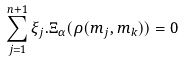Convert formula to latex. <formula><loc_0><loc_0><loc_500><loc_500>\sum _ { j = 1 } ^ { n + 1 } \xi _ { j } . \Xi _ { \alpha } ( \rho ( m _ { j } , m _ { k } ) ) = 0</formula> 